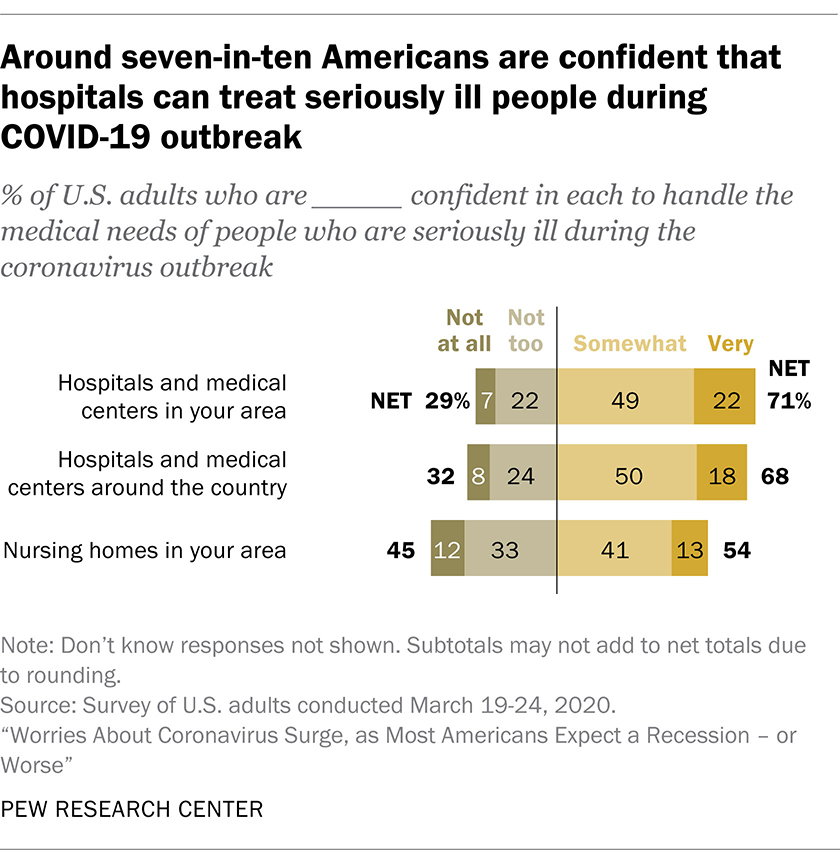Indicate a few pertinent items in this graphic. The place with the highest level of confidence among hospitals and medical centers in the area is... Out of the 54 responses received for 'nursing homes in your area', 54 indicate a positive response. 